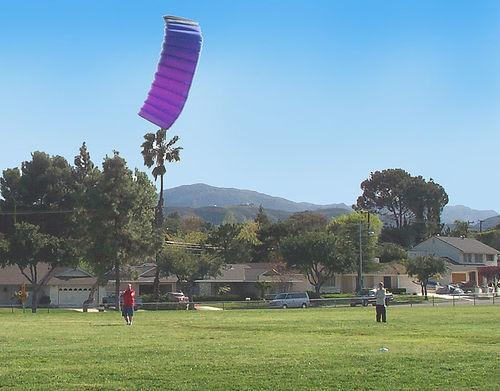What does the man in red hold in his hands? kite 